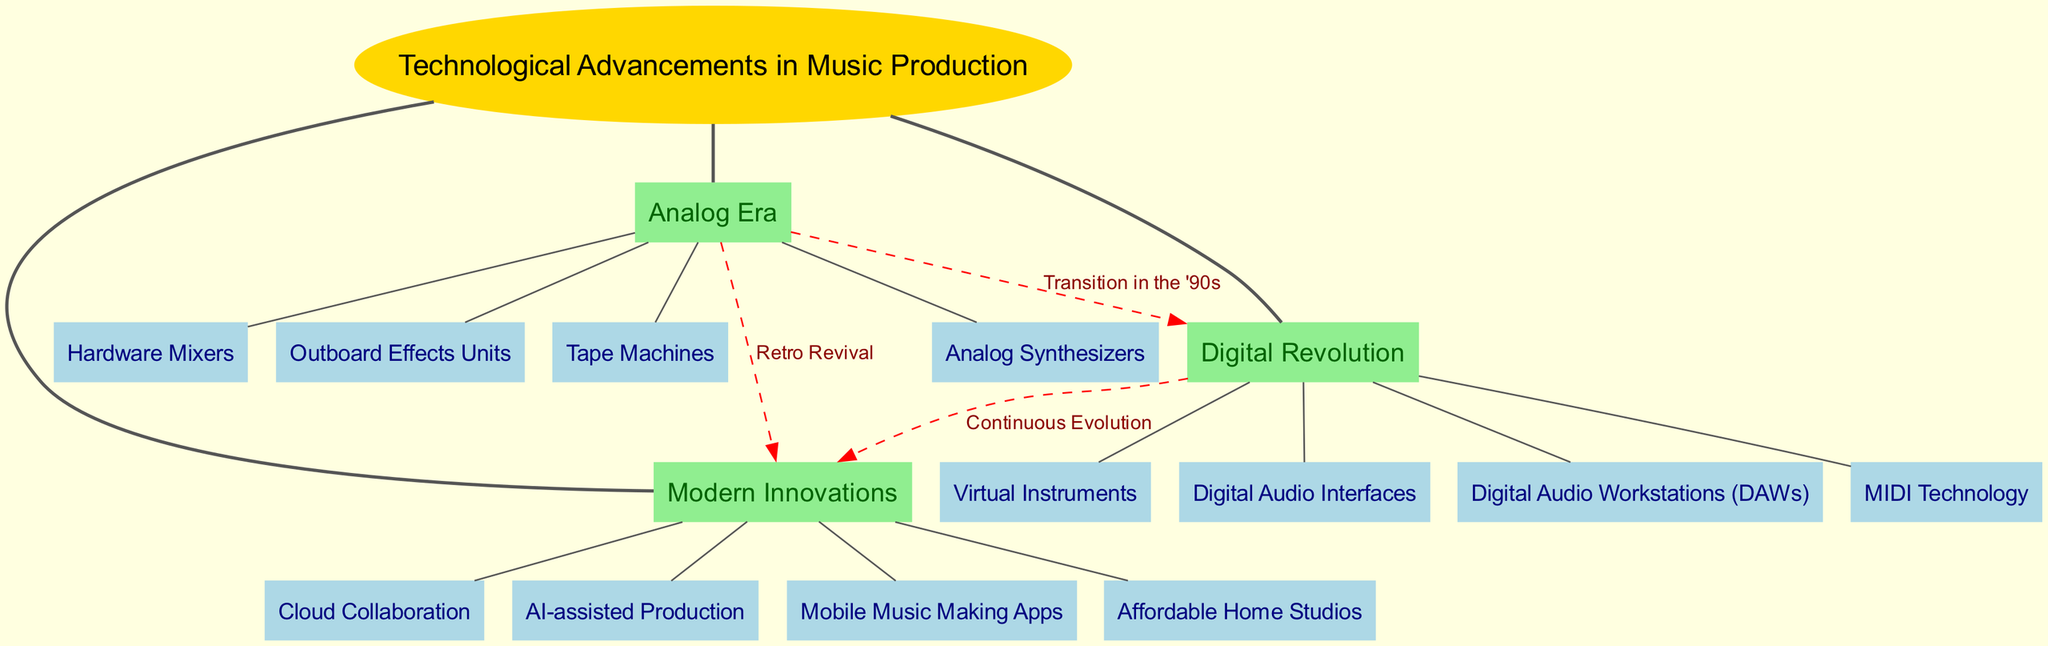What is the central concept of the diagram? The central concept is the main theme represented at the center of the diagram, which in this case is labeled "Technological Advancements in Music Production."
Answer: Technological Advancements in Music Production How many main branches are there? To determine the number of main branches, count the distinct branches stemming directly from the central concept. There are three branches: Analog Era, Digital Revolution, and Modern Innovations.
Answer: 3 What connects the Analog Era to the Digital Revolution? The connection between the Analog Era and the Digital Revolution is labeled "Transition in the '90s" as indicated by the dashed line between these two branches.
Answer: Transition in the '90s Name one subbranch under Digital Revolution. By looking at the subbranches under the Digital Revolution branch, one can find "Digital Audio Workstations (DAWs)" as one of the listed subbranches.
Answer: Digital Audio Workstations (DAWs) Which branch leads into Modern Innovations with a label of "Continuous Evolution"? The connection labeled "Continuous Evolution" leads from the Digital Revolution branch into Modern Innovations, indicating an ongoing progression from one to the other.
Answer: Digital Revolution What subbranch is linked to both the Analog Era and Modern Innovations? The Retro Revival connection indicates that the Analog Era is associated with Modern Innovations, reflecting on the influence of the past on current technology.
Answer: Retro Revival How many subbranches are under the Modern Innovations branch? By examining the Modern Innovations branch, it can be seen that there are four subbranches listed, which are Cloud Collaboration, AI-assisted Production, Mobile Music Making Apps, and Affordable Home Studios.
Answer: 4 What type of music production equipment is associated with the Analog Era? The subbranches of the Analog Era include Tape Machines, Analog Synthesizers, Hardware Mixers, and Outboard Effects Units; therefore, one piece of equipment associated is "Tape Machines."
Answer: Tape Machines What does the dashed line represent in the diagram? The dashed line signifies a type of relationship or connection between two branches, specifically indicating a transformation or evolution between them, such as between the Analog Era and Digital Revolution.
Answer: Relationship or connection 